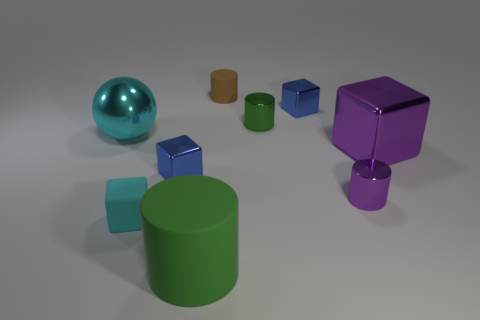The large metallic thing that is behind the large purple metallic thing is what color? cyan 